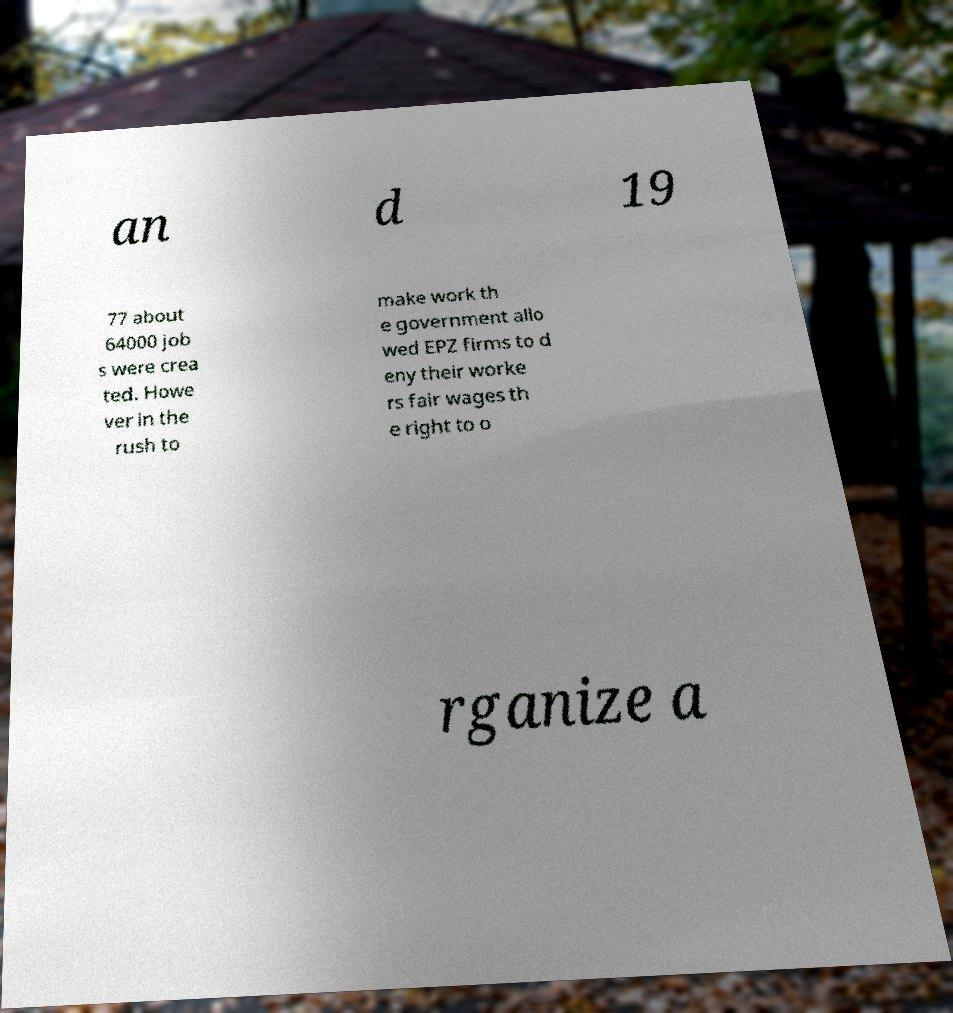Could you assist in decoding the text presented in this image and type it out clearly? an d 19 77 about 64000 job s were crea ted. Howe ver in the rush to make work th e government allo wed EPZ firms to d eny their worke rs fair wages th e right to o rganize a 